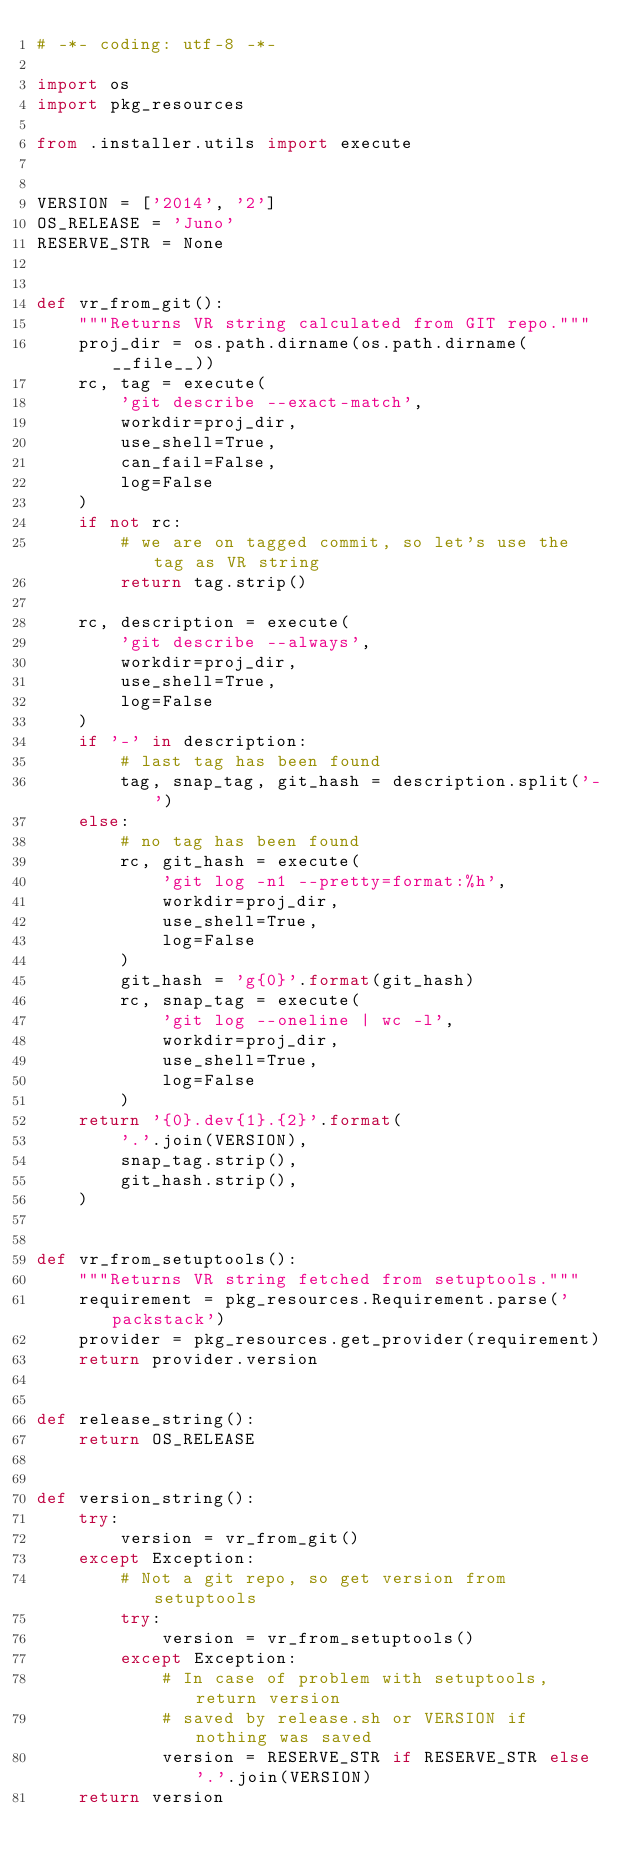Convert code to text. <code><loc_0><loc_0><loc_500><loc_500><_Python_># -*- coding: utf-8 -*-

import os
import pkg_resources

from .installer.utils import execute


VERSION = ['2014', '2']
OS_RELEASE = 'Juno'
RESERVE_STR = None


def vr_from_git():
    """Returns VR string calculated from GIT repo."""
    proj_dir = os.path.dirname(os.path.dirname(__file__))
    rc, tag = execute(
        'git describe --exact-match',
        workdir=proj_dir,
        use_shell=True,
        can_fail=False,
        log=False
    )
    if not rc:
        # we are on tagged commit, so let's use the tag as VR string
        return tag.strip()

    rc, description = execute(
        'git describe --always',
        workdir=proj_dir,
        use_shell=True,
        log=False
    )
    if '-' in description:
        # last tag has been found
        tag, snap_tag, git_hash = description.split('-')
    else:
        # no tag has been found
        rc, git_hash = execute(
            'git log -n1 --pretty=format:%h',
            workdir=proj_dir,
            use_shell=True,
            log=False
        )
        git_hash = 'g{0}'.format(git_hash)
        rc, snap_tag = execute(
            'git log --oneline | wc -l',
            workdir=proj_dir,
            use_shell=True,
            log=False
        )
    return '{0}.dev{1}.{2}'.format(
        '.'.join(VERSION),
        snap_tag.strip(),
        git_hash.strip(),
    )


def vr_from_setuptools():
    """Returns VR string fetched from setuptools."""
    requirement = pkg_resources.Requirement.parse('packstack')
    provider = pkg_resources.get_provider(requirement)
    return provider.version


def release_string():
    return OS_RELEASE


def version_string():
    try:
        version = vr_from_git()
    except Exception:
        # Not a git repo, so get version from setuptools
        try:
            version = vr_from_setuptools()
        except Exception:
            # In case of problem with setuptools, return version
            # saved by release.sh or VERSION if nothing was saved
            version = RESERVE_STR if RESERVE_STR else '.'.join(VERSION)
    return version
</code> 